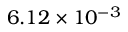<formula> <loc_0><loc_0><loc_500><loc_500>6 . 1 2 \times 1 0 ^ { - 3 }</formula> 